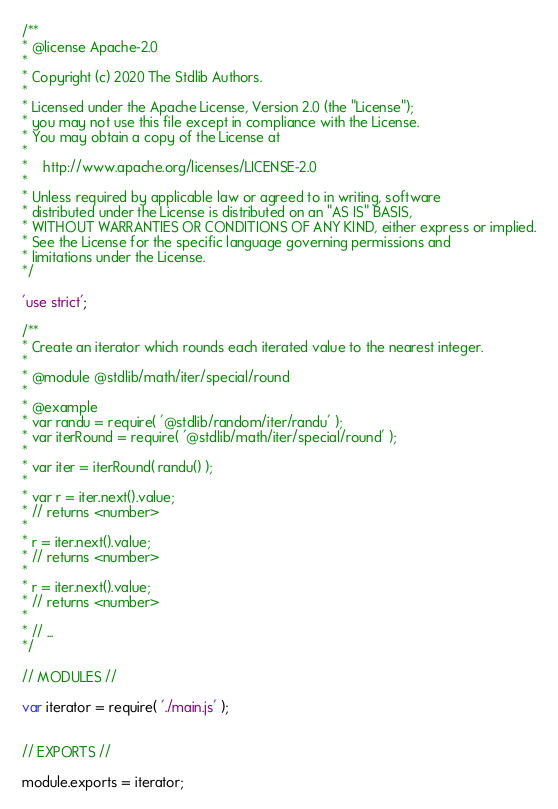<code> <loc_0><loc_0><loc_500><loc_500><_JavaScript_>/**
* @license Apache-2.0
*
* Copyright (c) 2020 The Stdlib Authors.
*
* Licensed under the Apache License, Version 2.0 (the "License");
* you may not use this file except in compliance with the License.
* You may obtain a copy of the License at
*
*    http://www.apache.org/licenses/LICENSE-2.0
*
* Unless required by applicable law or agreed to in writing, software
* distributed under the License is distributed on an "AS IS" BASIS,
* WITHOUT WARRANTIES OR CONDITIONS OF ANY KIND, either express or implied.
* See the License for the specific language governing permissions and
* limitations under the License.
*/

'use strict';

/**
* Create an iterator which rounds each iterated value to the nearest integer.
*
* @module @stdlib/math/iter/special/round
*
* @example
* var randu = require( '@stdlib/random/iter/randu' );
* var iterRound = require( '@stdlib/math/iter/special/round' );
*
* var iter = iterRound( randu() );
*
* var r = iter.next().value;
* // returns <number>
*
* r = iter.next().value;
* // returns <number>
*
* r = iter.next().value;
* // returns <number>
*
* // ...
*/

// MODULES //

var iterator = require( './main.js' );


// EXPORTS //

module.exports = iterator;
</code> 